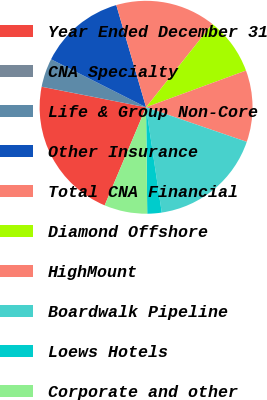<chart> <loc_0><loc_0><loc_500><loc_500><pie_chart><fcel>Year Ended December 31<fcel>CNA Specialty<fcel>Life & Group Non-Core<fcel>Other Insurance<fcel>Total CNA Financial<fcel>Diamond Offshore<fcel>HighMount<fcel>Boardwalk Pipeline<fcel>Loews Hotels<fcel>Corporate and other<nl><fcel>21.73%<fcel>0.01%<fcel>4.35%<fcel>13.04%<fcel>15.21%<fcel>8.7%<fcel>10.87%<fcel>17.38%<fcel>2.18%<fcel>6.53%<nl></chart> 